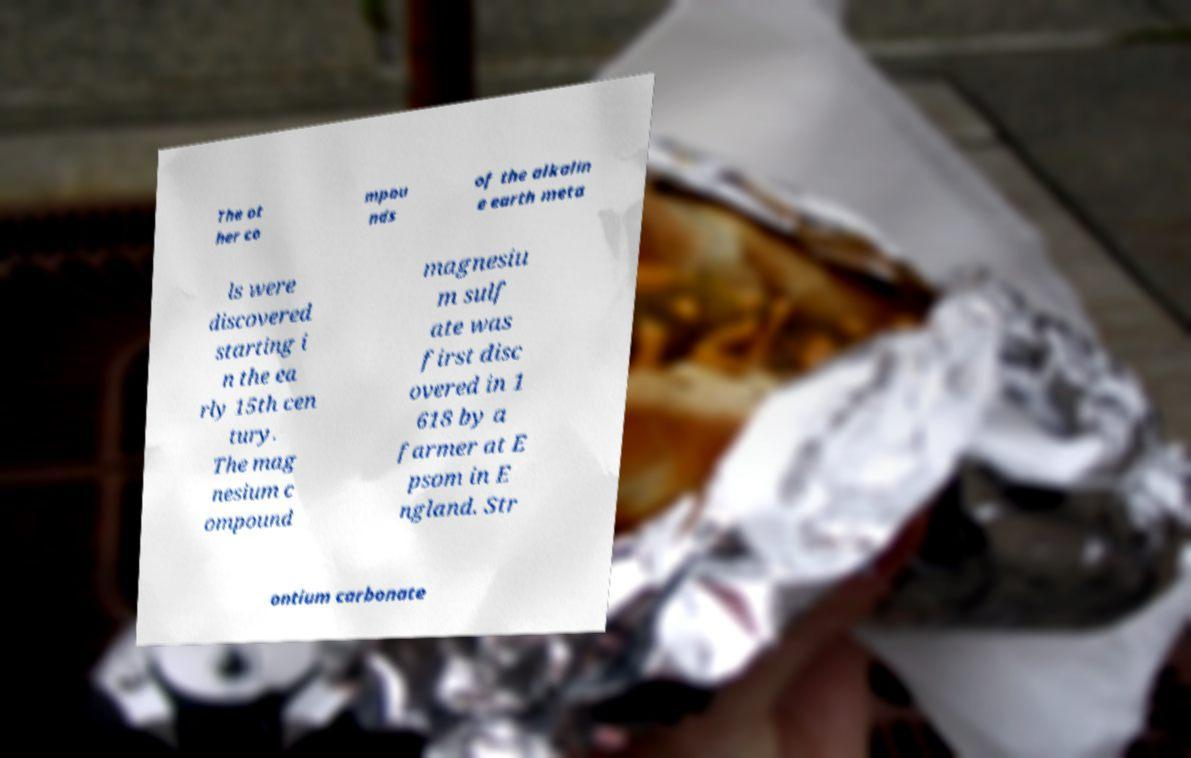For documentation purposes, I need the text within this image transcribed. Could you provide that? The ot her co mpou nds of the alkalin e earth meta ls were discovered starting i n the ea rly 15th cen tury. The mag nesium c ompound magnesiu m sulf ate was first disc overed in 1 618 by a farmer at E psom in E ngland. Str ontium carbonate 